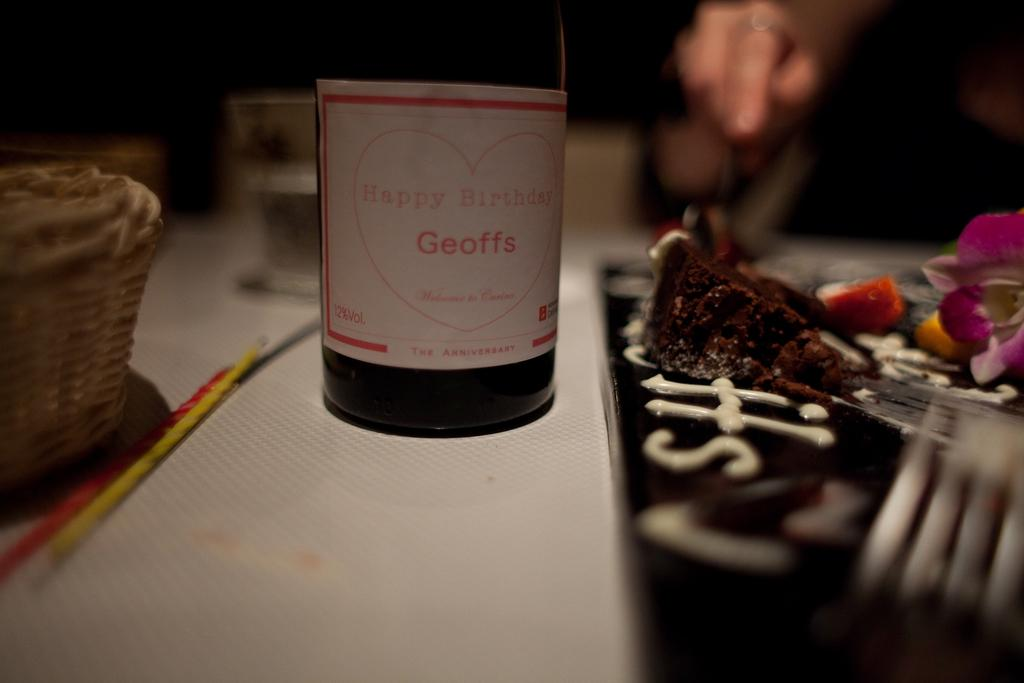<image>
Share a concise interpretation of the image provided. "Happy Birthday Geoffs" is on a bottle label. 